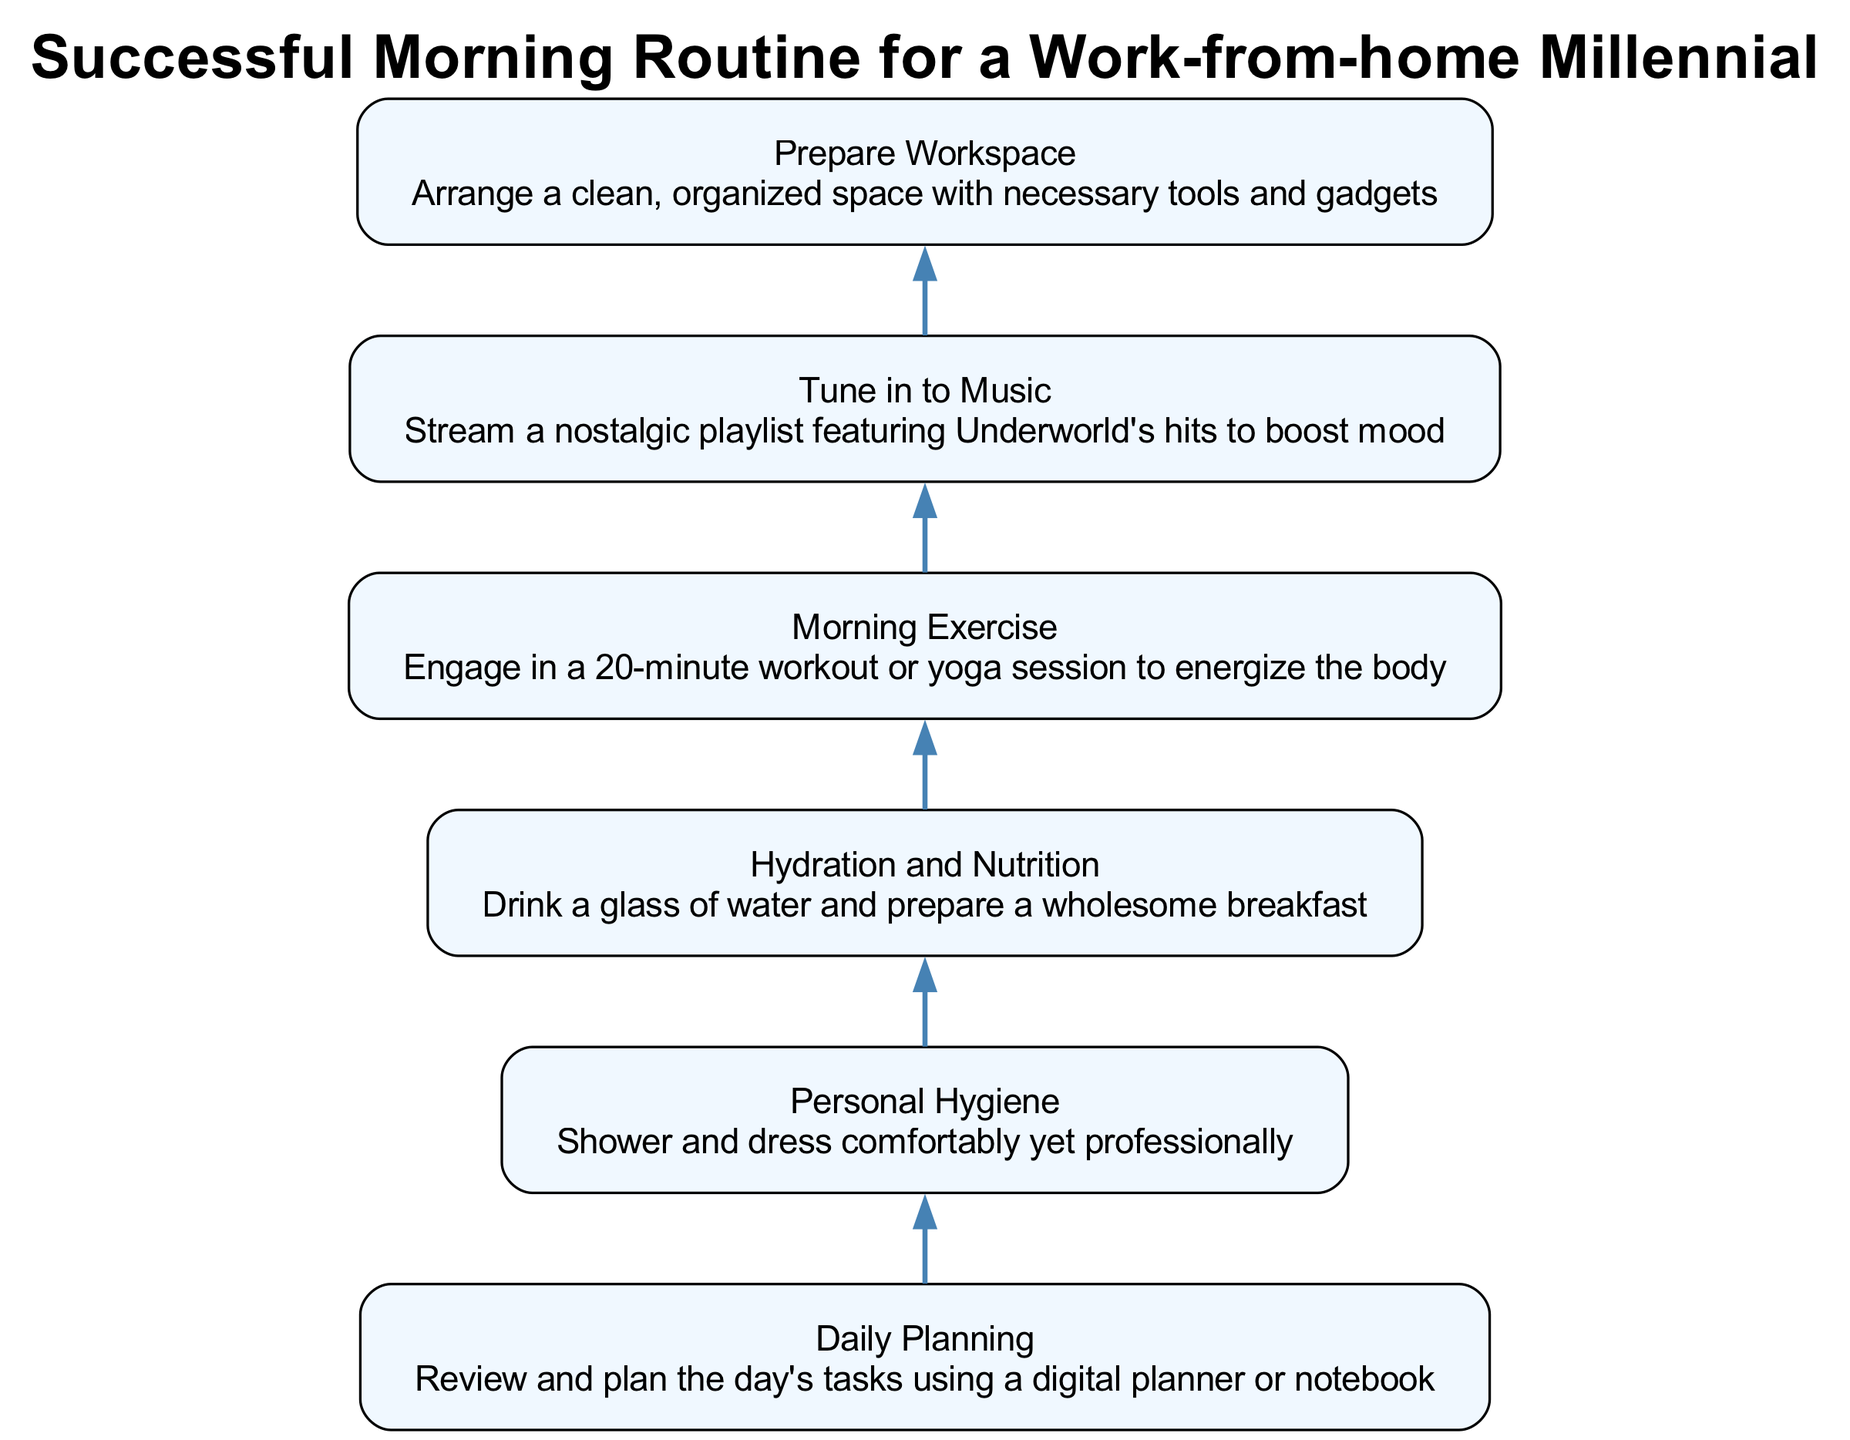What is the first step in the morning routine? The first step in the morning routine is the "Prepare Workspace," which involves arranging a clean and organized space with necessary tools and gadgets.
Answer: Prepare Workspace How many steps are there in total? By counting all unique steps from "Prepare Workspace" through "Daily Planning," there are a total of six steps in the diagram.
Answer: 6 Which step immediately follows "Hydration and Nutrition"? The step immediately following "Hydration and Nutrition" is "Personal Hygiene," which involves showering and dressing comfortably yet professionally.
Answer: Personal Hygiene What is the last step in the morning routine? The last step in the morning routine is "Daily Planning," where one would review and plan the day's tasks using a digital planner or notebook.
Answer: Daily Planning Which step features engaging in a workout? The step where engaging in a workout occurs is "Morning Exercise," which involves a 20-minute workout or yoga session to energize the body.
Answer: Morning Exercise What is the relationship between "Tune in to Music" and "Morning Exercise"? The relationship is sequential; "Tune in to Music" flows directly into "Morning Exercise," indicating that music is enjoyed before exercising.
Answer: Sequential In what stage do you drink water? You drink water during the "Hydration and Nutrition" stage, which involves drinking a glass of water and preparing a wholesome breakfast.
Answer: Hydration and Nutrition Is "Daily Planning" dependent on any previous step? Yes, "Daily Planning" is dependent on all previous steps, as it completes the routine by reviewing and planning the day after completing earlier tasks.
Answer: Yes What kind of music is suggested in the second step? The suggested music in the second step is a nostalgic playlist featuring Underworld's hits, aimed at boosting mood.
Answer: Underworld's hits 